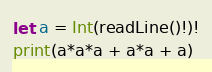Convert code to text. <code><loc_0><loc_0><loc_500><loc_500><_Swift_>let a = Int(readLine()!)!
print(a*a*a + a*a + a)</code> 